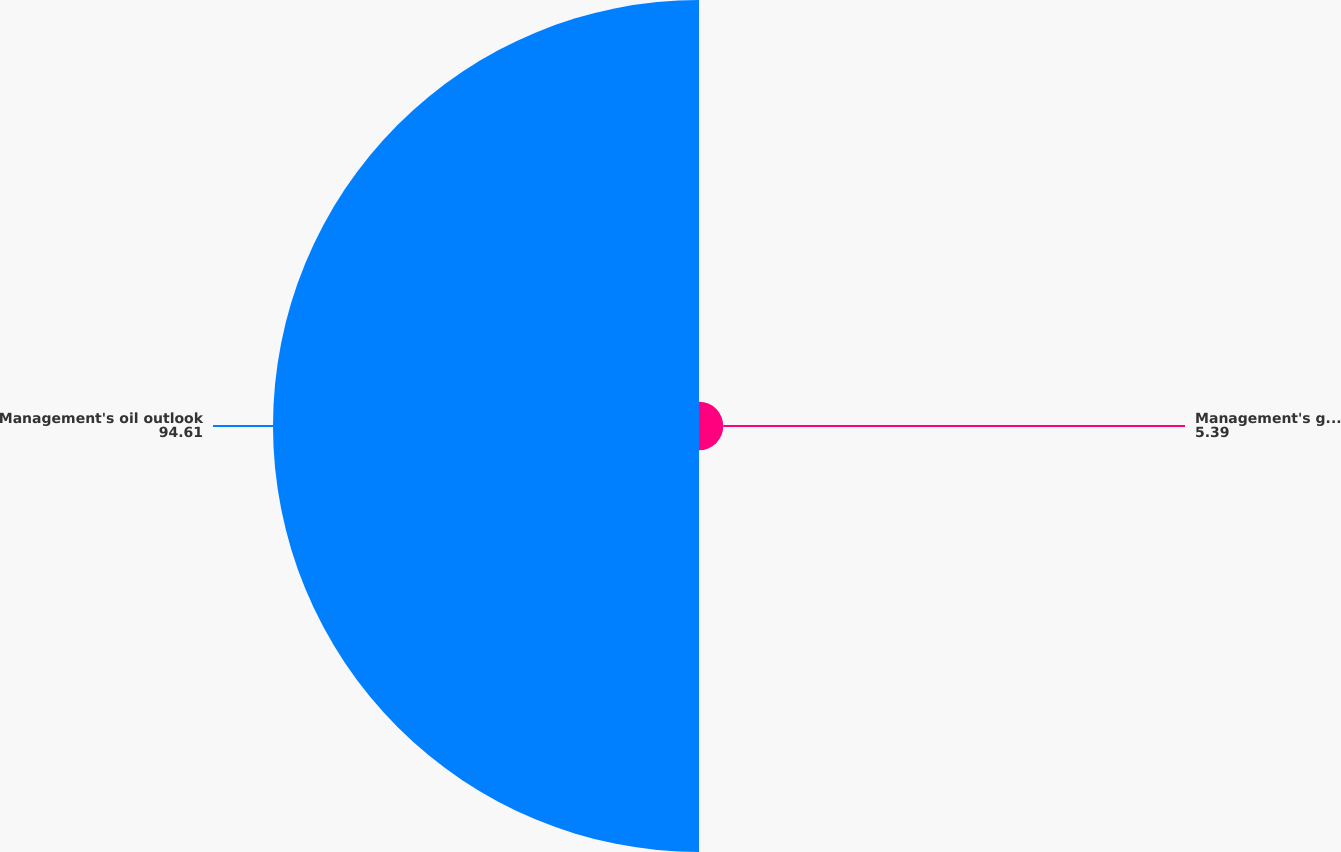Convert chart to OTSL. <chart><loc_0><loc_0><loc_500><loc_500><pie_chart><fcel>Management's gas outlook<fcel>Management's oil outlook<nl><fcel>5.39%<fcel>94.61%<nl></chart> 